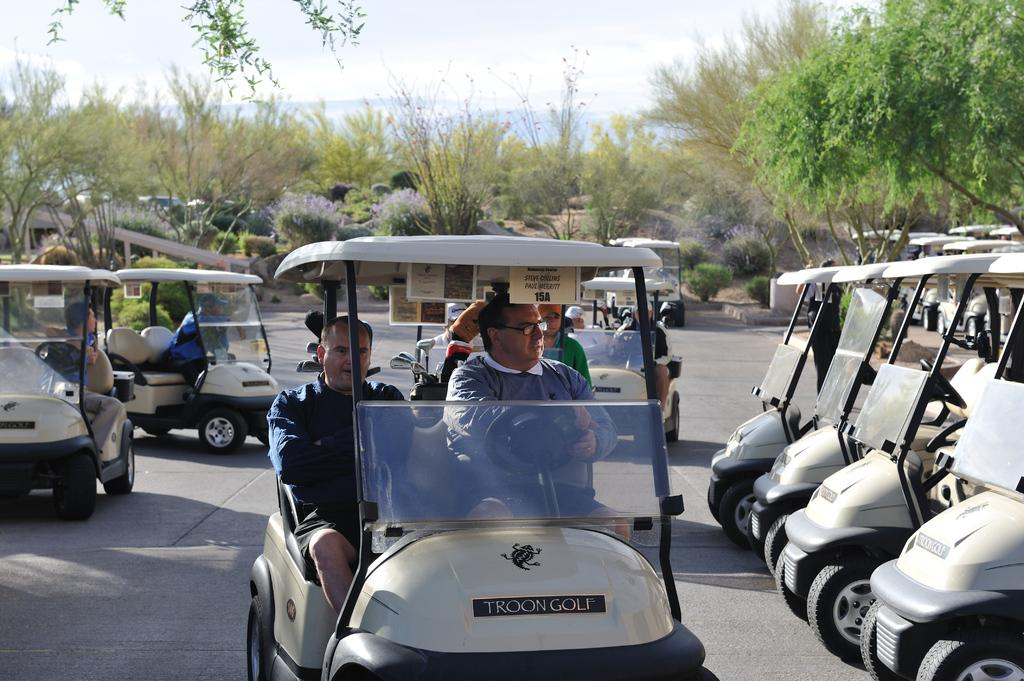What are the people in the image doing? The people in the image are riding vehicles. What can be seen on the right side of the image? There are empty vehicles on the right side of the image. What is visible in the background of the image? There are trees and plants in the background of the image. What type of representative can be seen in the image? There is no representative present in the image; it features people riding vehicles and empty vehicles. What kind of beast is interacting with the trees in the image? There is no beast present in the image; it only shows people riding vehicles, empty vehicles, trees, and plants. 